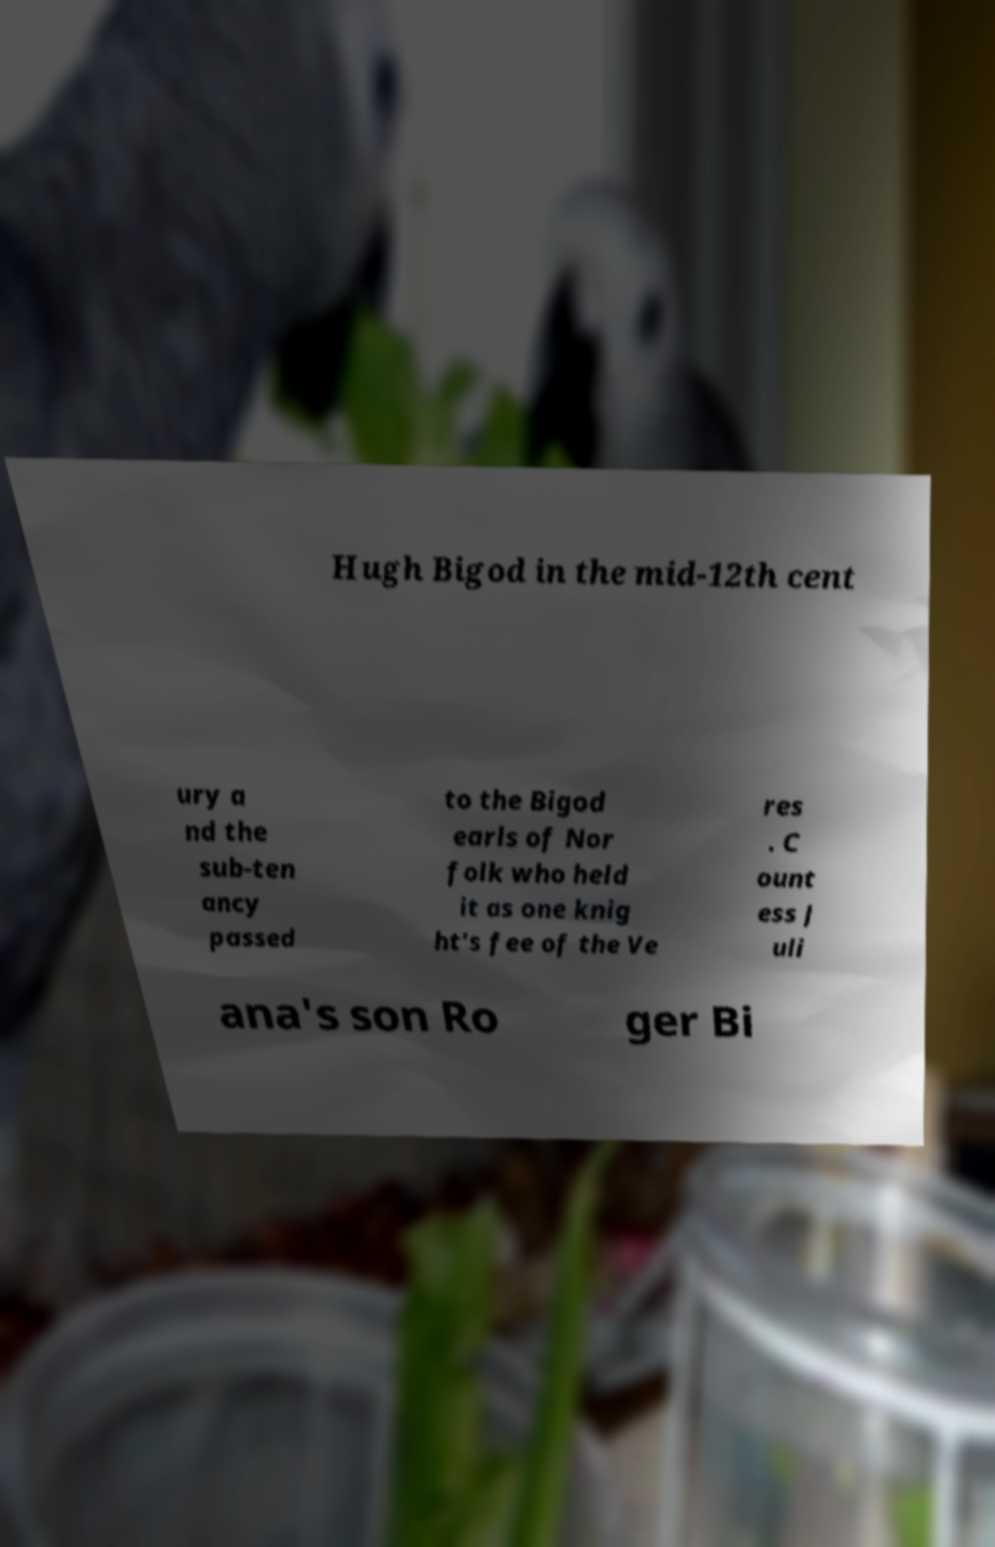Please read and relay the text visible in this image. What does it say? Hugh Bigod in the mid-12th cent ury a nd the sub-ten ancy passed to the Bigod earls of Nor folk who held it as one knig ht's fee of the Ve res . C ount ess J uli ana's son Ro ger Bi 